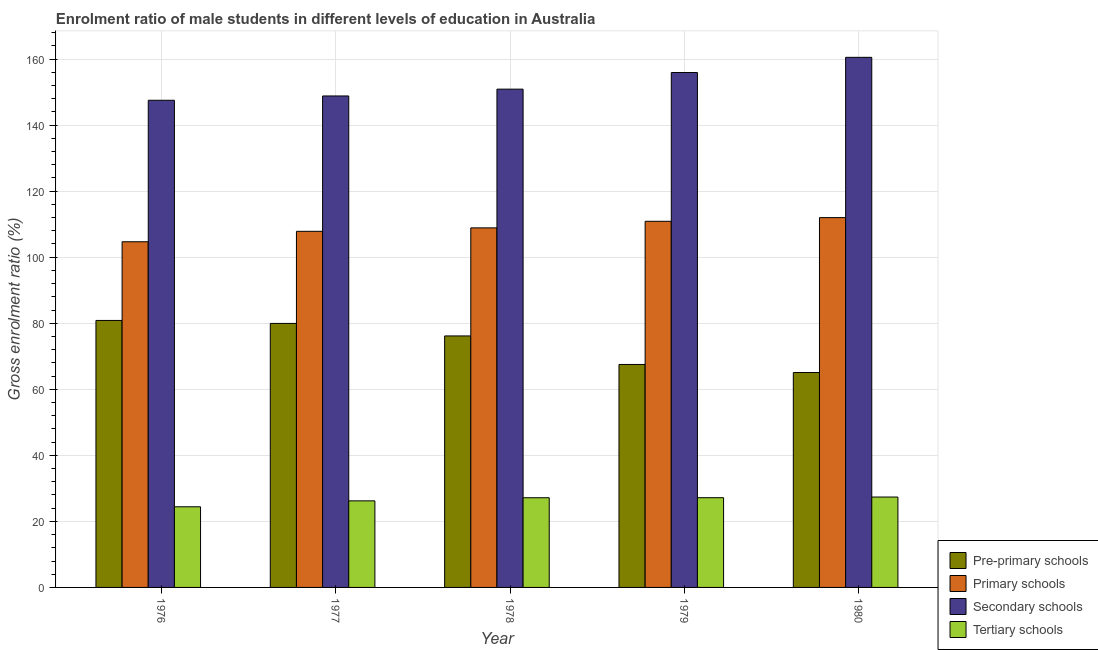How many different coloured bars are there?
Ensure brevity in your answer.  4. How many groups of bars are there?
Give a very brief answer. 5. Are the number of bars per tick equal to the number of legend labels?
Your response must be concise. Yes. Are the number of bars on each tick of the X-axis equal?
Keep it short and to the point. Yes. What is the label of the 3rd group of bars from the left?
Keep it short and to the point. 1978. What is the gross enrolment ratio(female) in tertiary schools in 1980?
Offer a very short reply. 27.37. Across all years, what is the maximum gross enrolment ratio(female) in primary schools?
Ensure brevity in your answer.  111.98. Across all years, what is the minimum gross enrolment ratio(female) in secondary schools?
Provide a succinct answer. 147.52. In which year was the gross enrolment ratio(female) in secondary schools minimum?
Ensure brevity in your answer.  1976. What is the total gross enrolment ratio(female) in secondary schools in the graph?
Keep it short and to the point. 763.66. What is the difference between the gross enrolment ratio(female) in pre-primary schools in 1977 and that in 1978?
Provide a short and direct response. 3.79. What is the difference between the gross enrolment ratio(female) in pre-primary schools in 1977 and the gross enrolment ratio(female) in tertiary schools in 1980?
Your response must be concise. 14.87. What is the average gross enrolment ratio(female) in tertiary schools per year?
Give a very brief answer. 26.47. In the year 1980, what is the difference between the gross enrolment ratio(female) in tertiary schools and gross enrolment ratio(female) in pre-primary schools?
Your response must be concise. 0. What is the ratio of the gross enrolment ratio(female) in pre-primary schools in 1977 to that in 1980?
Your answer should be very brief. 1.23. Is the gross enrolment ratio(female) in pre-primary schools in 1976 less than that in 1979?
Offer a terse response. No. Is the difference between the gross enrolment ratio(female) in primary schools in 1976 and 1980 greater than the difference between the gross enrolment ratio(female) in pre-primary schools in 1976 and 1980?
Your answer should be compact. No. What is the difference between the highest and the second highest gross enrolment ratio(female) in tertiary schools?
Provide a succinct answer. 0.2. What is the difference between the highest and the lowest gross enrolment ratio(female) in primary schools?
Provide a short and direct response. 7.31. Is the sum of the gross enrolment ratio(female) in tertiary schools in 1977 and 1979 greater than the maximum gross enrolment ratio(female) in pre-primary schools across all years?
Your answer should be compact. Yes. Is it the case that in every year, the sum of the gross enrolment ratio(female) in secondary schools and gross enrolment ratio(female) in primary schools is greater than the sum of gross enrolment ratio(female) in tertiary schools and gross enrolment ratio(female) in pre-primary schools?
Give a very brief answer. Yes. What does the 3rd bar from the left in 1979 represents?
Your response must be concise. Secondary schools. What does the 2nd bar from the right in 1979 represents?
Offer a very short reply. Secondary schools. Are all the bars in the graph horizontal?
Your answer should be compact. No. How many years are there in the graph?
Keep it short and to the point. 5. Does the graph contain any zero values?
Offer a terse response. No. Does the graph contain grids?
Give a very brief answer. Yes. Where does the legend appear in the graph?
Keep it short and to the point. Bottom right. How are the legend labels stacked?
Your answer should be very brief. Vertical. What is the title of the graph?
Keep it short and to the point. Enrolment ratio of male students in different levels of education in Australia. What is the label or title of the X-axis?
Your answer should be very brief. Year. What is the label or title of the Y-axis?
Offer a very short reply. Gross enrolment ratio (%). What is the Gross enrolment ratio (%) in Pre-primary schools in 1976?
Provide a succinct answer. 80.84. What is the Gross enrolment ratio (%) in Primary schools in 1976?
Offer a very short reply. 104.67. What is the Gross enrolment ratio (%) in Secondary schools in 1976?
Offer a terse response. 147.52. What is the Gross enrolment ratio (%) of Tertiary schools in 1976?
Offer a very short reply. 24.42. What is the Gross enrolment ratio (%) in Pre-primary schools in 1977?
Your response must be concise. 79.95. What is the Gross enrolment ratio (%) of Primary schools in 1977?
Keep it short and to the point. 107.83. What is the Gross enrolment ratio (%) of Secondary schools in 1977?
Ensure brevity in your answer.  148.82. What is the Gross enrolment ratio (%) of Tertiary schools in 1977?
Provide a short and direct response. 26.22. What is the Gross enrolment ratio (%) in Pre-primary schools in 1978?
Give a very brief answer. 76.15. What is the Gross enrolment ratio (%) of Primary schools in 1978?
Ensure brevity in your answer.  108.88. What is the Gross enrolment ratio (%) in Secondary schools in 1978?
Offer a very short reply. 150.89. What is the Gross enrolment ratio (%) of Tertiary schools in 1978?
Provide a short and direct response. 27.16. What is the Gross enrolment ratio (%) in Pre-primary schools in 1979?
Keep it short and to the point. 67.52. What is the Gross enrolment ratio (%) in Primary schools in 1979?
Offer a very short reply. 110.87. What is the Gross enrolment ratio (%) of Secondary schools in 1979?
Your answer should be very brief. 155.92. What is the Gross enrolment ratio (%) in Tertiary schools in 1979?
Offer a very short reply. 27.17. What is the Gross enrolment ratio (%) of Pre-primary schools in 1980?
Give a very brief answer. 65.08. What is the Gross enrolment ratio (%) of Primary schools in 1980?
Offer a terse response. 111.98. What is the Gross enrolment ratio (%) of Secondary schools in 1980?
Provide a succinct answer. 160.52. What is the Gross enrolment ratio (%) of Tertiary schools in 1980?
Give a very brief answer. 27.37. Across all years, what is the maximum Gross enrolment ratio (%) of Pre-primary schools?
Offer a very short reply. 80.84. Across all years, what is the maximum Gross enrolment ratio (%) of Primary schools?
Offer a very short reply. 111.98. Across all years, what is the maximum Gross enrolment ratio (%) in Secondary schools?
Make the answer very short. 160.52. Across all years, what is the maximum Gross enrolment ratio (%) in Tertiary schools?
Offer a very short reply. 27.37. Across all years, what is the minimum Gross enrolment ratio (%) of Pre-primary schools?
Provide a succinct answer. 65.08. Across all years, what is the minimum Gross enrolment ratio (%) of Primary schools?
Give a very brief answer. 104.67. Across all years, what is the minimum Gross enrolment ratio (%) in Secondary schools?
Provide a succinct answer. 147.52. Across all years, what is the minimum Gross enrolment ratio (%) in Tertiary schools?
Provide a short and direct response. 24.42. What is the total Gross enrolment ratio (%) of Pre-primary schools in the graph?
Your answer should be very brief. 369.54. What is the total Gross enrolment ratio (%) in Primary schools in the graph?
Keep it short and to the point. 544.24. What is the total Gross enrolment ratio (%) of Secondary schools in the graph?
Your answer should be compact. 763.66. What is the total Gross enrolment ratio (%) in Tertiary schools in the graph?
Offer a very short reply. 132.33. What is the difference between the Gross enrolment ratio (%) in Pre-primary schools in 1976 and that in 1977?
Offer a very short reply. 0.9. What is the difference between the Gross enrolment ratio (%) of Primary schools in 1976 and that in 1977?
Provide a succinct answer. -3.16. What is the difference between the Gross enrolment ratio (%) of Secondary schools in 1976 and that in 1977?
Keep it short and to the point. -1.31. What is the difference between the Gross enrolment ratio (%) of Tertiary schools in 1976 and that in 1977?
Provide a succinct answer. -1.8. What is the difference between the Gross enrolment ratio (%) in Pre-primary schools in 1976 and that in 1978?
Your response must be concise. 4.69. What is the difference between the Gross enrolment ratio (%) in Primary schools in 1976 and that in 1978?
Keep it short and to the point. -4.21. What is the difference between the Gross enrolment ratio (%) in Secondary schools in 1976 and that in 1978?
Make the answer very short. -3.37. What is the difference between the Gross enrolment ratio (%) of Tertiary schools in 1976 and that in 1978?
Your answer should be compact. -2.74. What is the difference between the Gross enrolment ratio (%) of Pre-primary schools in 1976 and that in 1979?
Provide a succinct answer. 13.33. What is the difference between the Gross enrolment ratio (%) of Primary schools in 1976 and that in 1979?
Make the answer very short. -6.2. What is the difference between the Gross enrolment ratio (%) of Secondary schools in 1976 and that in 1979?
Give a very brief answer. -8.4. What is the difference between the Gross enrolment ratio (%) of Tertiary schools in 1976 and that in 1979?
Offer a very short reply. -2.75. What is the difference between the Gross enrolment ratio (%) in Pre-primary schools in 1976 and that in 1980?
Ensure brevity in your answer.  15.77. What is the difference between the Gross enrolment ratio (%) in Primary schools in 1976 and that in 1980?
Offer a very short reply. -7.31. What is the difference between the Gross enrolment ratio (%) of Secondary schools in 1976 and that in 1980?
Give a very brief answer. -13. What is the difference between the Gross enrolment ratio (%) in Tertiary schools in 1976 and that in 1980?
Keep it short and to the point. -2.95. What is the difference between the Gross enrolment ratio (%) of Pre-primary schools in 1977 and that in 1978?
Provide a succinct answer. 3.79. What is the difference between the Gross enrolment ratio (%) of Primary schools in 1977 and that in 1978?
Give a very brief answer. -1.05. What is the difference between the Gross enrolment ratio (%) of Secondary schools in 1977 and that in 1978?
Your answer should be compact. -2.06. What is the difference between the Gross enrolment ratio (%) of Tertiary schools in 1977 and that in 1978?
Your response must be concise. -0.94. What is the difference between the Gross enrolment ratio (%) of Pre-primary schools in 1977 and that in 1979?
Offer a very short reply. 12.43. What is the difference between the Gross enrolment ratio (%) of Primary schools in 1977 and that in 1979?
Keep it short and to the point. -3.04. What is the difference between the Gross enrolment ratio (%) of Secondary schools in 1977 and that in 1979?
Make the answer very short. -7.1. What is the difference between the Gross enrolment ratio (%) in Tertiary schools in 1977 and that in 1979?
Your response must be concise. -0.96. What is the difference between the Gross enrolment ratio (%) in Pre-primary schools in 1977 and that in 1980?
Ensure brevity in your answer.  14.87. What is the difference between the Gross enrolment ratio (%) of Primary schools in 1977 and that in 1980?
Offer a very short reply. -4.15. What is the difference between the Gross enrolment ratio (%) of Secondary schools in 1977 and that in 1980?
Your answer should be compact. -11.7. What is the difference between the Gross enrolment ratio (%) in Tertiary schools in 1977 and that in 1980?
Make the answer very short. -1.15. What is the difference between the Gross enrolment ratio (%) in Pre-primary schools in 1978 and that in 1979?
Give a very brief answer. 8.64. What is the difference between the Gross enrolment ratio (%) in Primary schools in 1978 and that in 1979?
Your response must be concise. -1.99. What is the difference between the Gross enrolment ratio (%) of Secondary schools in 1978 and that in 1979?
Make the answer very short. -5.03. What is the difference between the Gross enrolment ratio (%) of Tertiary schools in 1978 and that in 1979?
Ensure brevity in your answer.  -0.01. What is the difference between the Gross enrolment ratio (%) in Pre-primary schools in 1978 and that in 1980?
Offer a very short reply. 11.08. What is the difference between the Gross enrolment ratio (%) in Primary schools in 1978 and that in 1980?
Provide a short and direct response. -3.1. What is the difference between the Gross enrolment ratio (%) of Secondary schools in 1978 and that in 1980?
Give a very brief answer. -9.63. What is the difference between the Gross enrolment ratio (%) in Tertiary schools in 1978 and that in 1980?
Provide a succinct answer. -0.21. What is the difference between the Gross enrolment ratio (%) in Pre-primary schools in 1979 and that in 1980?
Keep it short and to the point. 2.44. What is the difference between the Gross enrolment ratio (%) of Primary schools in 1979 and that in 1980?
Give a very brief answer. -1.11. What is the difference between the Gross enrolment ratio (%) in Secondary schools in 1979 and that in 1980?
Offer a very short reply. -4.6. What is the difference between the Gross enrolment ratio (%) in Tertiary schools in 1979 and that in 1980?
Provide a succinct answer. -0.2. What is the difference between the Gross enrolment ratio (%) of Pre-primary schools in 1976 and the Gross enrolment ratio (%) of Primary schools in 1977?
Your response must be concise. -26.99. What is the difference between the Gross enrolment ratio (%) in Pre-primary schools in 1976 and the Gross enrolment ratio (%) in Secondary schools in 1977?
Your answer should be very brief. -67.98. What is the difference between the Gross enrolment ratio (%) of Pre-primary schools in 1976 and the Gross enrolment ratio (%) of Tertiary schools in 1977?
Your answer should be compact. 54.63. What is the difference between the Gross enrolment ratio (%) of Primary schools in 1976 and the Gross enrolment ratio (%) of Secondary schools in 1977?
Offer a terse response. -44.15. What is the difference between the Gross enrolment ratio (%) in Primary schools in 1976 and the Gross enrolment ratio (%) in Tertiary schools in 1977?
Provide a short and direct response. 78.46. What is the difference between the Gross enrolment ratio (%) in Secondary schools in 1976 and the Gross enrolment ratio (%) in Tertiary schools in 1977?
Your answer should be compact. 121.3. What is the difference between the Gross enrolment ratio (%) of Pre-primary schools in 1976 and the Gross enrolment ratio (%) of Primary schools in 1978?
Keep it short and to the point. -28.04. What is the difference between the Gross enrolment ratio (%) of Pre-primary schools in 1976 and the Gross enrolment ratio (%) of Secondary schools in 1978?
Your answer should be very brief. -70.04. What is the difference between the Gross enrolment ratio (%) in Pre-primary schools in 1976 and the Gross enrolment ratio (%) in Tertiary schools in 1978?
Your answer should be very brief. 53.69. What is the difference between the Gross enrolment ratio (%) of Primary schools in 1976 and the Gross enrolment ratio (%) of Secondary schools in 1978?
Provide a succinct answer. -46.21. What is the difference between the Gross enrolment ratio (%) in Primary schools in 1976 and the Gross enrolment ratio (%) in Tertiary schools in 1978?
Your answer should be very brief. 77.51. What is the difference between the Gross enrolment ratio (%) of Secondary schools in 1976 and the Gross enrolment ratio (%) of Tertiary schools in 1978?
Ensure brevity in your answer.  120.36. What is the difference between the Gross enrolment ratio (%) in Pre-primary schools in 1976 and the Gross enrolment ratio (%) in Primary schools in 1979?
Offer a terse response. -30.03. What is the difference between the Gross enrolment ratio (%) in Pre-primary schools in 1976 and the Gross enrolment ratio (%) in Secondary schools in 1979?
Offer a very short reply. -75.07. What is the difference between the Gross enrolment ratio (%) in Pre-primary schools in 1976 and the Gross enrolment ratio (%) in Tertiary schools in 1979?
Your answer should be very brief. 53.67. What is the difference between the Gross enrolment ratio (%) in Primary schools in 1976 and the Gross enrolment ratio (%) in Secondary schools in 1979?
Give a very brief answer. -51.25. What is the difference between the Gross enrolment ratio (%) in Primary schools in 1976 and the Gross enrolment ratio (%) in Tertiary schools in 1979?
Your answer should be compact. 77.5. What is the difference between the Gross enrolment ratio (%) in Secondary schools in 1976 and the Gross enrolment ratio (%) in Tertiary schools in 1979?
Offer a very short reply. 120.34. What is the difference between the Gross enrolment ratio (%) of Pre-primary schools in 1976 and the Gross enrolment ratio (%) of Primary schools in 1980?
Your response must be concise. -31.14. What is the difference between the Gross enrolment ratio (%) in Pre-primary schools in 1976 and the Gross enrolment ratio (%) in Secondary schools in 1980?
Your response must be concise. -79.68. What is the difference between the Gross enrolment ratio (%) of Pre-primary schools in 1976 and the Gross enrolment ratio (%) of Tertiary schools in 1980?
Provide a short and direct response. 53.48. What is the difference between the Gross enrolment ratio (%) of Primary schools in 1976 and the Gross enrolment ratio (%) of Secondary schools in 1980?
Provide a short and direct response. -55.85. What is the difference between the Gross enrolment ratio (%) of Primary schools in 1976 and the Gross enrolment ratio (%) of Tertiary schools in 1980?
Provide a short and direct response. 77.3. What is the difference between the Gross enrolment ratio (%) in Secondary schools in 1976 and the Gross enrolment ratio (%) in Tertiary schools in 1980?
Keep it short and to the point. 120.15. What is the difference between the Gross enrolment ratio (%) in Pre-primary schools in 1977 and the Gross enrolment ratio (%) in Primary schools in 1978?
Give a very brief answer. -28.93. What is the difference between the Gross enrolment ratio (%) in Pre-primary schools in 1977 and the Gross enrolment ratio (%) in Secondary schools in 1978?
Your answer should be very brief. -70.94. What is the difference between the Gross enrolment ratio (%) of Pre-primary schools in 1977 and the Gross enrolment ratio (%) of Tertiary schools in 1978?
Provide a succinct answer. 52.79. What is the difference between the Gross enrolment ratio (%) in Primary schools in 1977 and the Gross enrolment ratio (%) in Secondary schools in 1978?
Your answer should be compact. -43.05. What is the difference between the Gross enrolment ratio (%) in Primary schools in 1977 and the Gross enrolment ratio (%) in Tertiary schools in 1978?
Give a very brief answer. 80.67. What is the difference between the Gross enrolment ratio (%) of Secondary schools in 1977 and the Gross enrolment ratio (%) of Tertiary schools in 1978?
Offer a very short reply. 121.66. What is the difference between the Gross enrolment ratio (%) in Pre-primary schools in 1977 and the Gross enrolment ratio (%) in Primary schools in 1979?
Your response must be concise. -30.93. What is the difference between the Gross enrolment ratio (%) of Pre-primary schools in 1977 and the Gross enrolment ratio (%) of Secondary schools in 1979?
Your response must be concise. -75.97. What is the difference between the Gross enrolment ratio (%) of Pre-primary schools in 1977 and the Gross enrolment ratio (%) of Tertiary schools in 1979?
Your answer should be very brief. 52.78. What is the difference between the Gross enrolment ratio (%) in Primary schools in 1977 and the Gross enrolment ratio (%) in Secondary schools in 1979?
Offer a very short reply. -48.09. What is the difference between the Gross enrolment ratio (%) in Primary schools in 1977 and the Gross enrolment ratio (%) in Tertiary schools in 1979?
Keep it short and to the point. 80.66. What is the difference between the Gross enrolment ratio (%) of Secondary schools in 1977 and the Gross enrolment ratio (%) of Tertiary schools in 1979?
Offer a very short reply. 121.65. What is the difference between the Gross enrolment ratio (%) in Pre-primary schools in 1977 and the Gross enrolment ratio (%) in Primary schools in 1980?
Ensure brevity in your answer.  -32.04. What is the difference between the Gross enrolment ratio (%) of Pre-primary schools in 1977 and the Gross enrolment ratio (%) of Secondary schools in 1980?
Ensure brevity in your answer.  -80.57. What is the difference between the Gross enrolment ratio (%) in Pre-primary schools in 1977 and the Gross enrolment ratio (%) in Tertiary schools in 1980?
Your response must be concise. 52.58. What is the difference between the Gross enrolment ratio (%) of Primary schools in 1977 and the Gross enrolment ratio (%) of Secondary schools in 1980?
Ensure brevity in your answer.  -52.69. What is the difference between the Gross enrolment ratio (%) of Primary schools in 1977 and the Gross enrolment ratio (%) of Tertiary schools in 1980?
Your answer should be very brief. 80.46. What is the difference between the Gross enrolment ratio (%) of Secondary schools in 1977 and the Gross enrolment ratio (%) of Tertiary schools in 1980?
Your answer should be compact. 121.45. What is the difference between the Gross enrolment ratio (%) in Pre-primary schools in 1978 and the Gross enrolment ratio (%) in Primary schools in 1979?
Keep it short and to the point. -34.72. What is the difference between the Gross enrolment ratio (%) of Pre-primary schools in 1978 and the Gross enrolment ratio (%) of Secondary schools in 1979?
Offer a terse response. -79.76. What is the difference between the Gross enrolment ratio (%) of Pre-primary schools in 1978 and the Gross enrolment ratio (%) of Tertiary schools in 1979?
Your response must be concise. 48.98. What is the difference between the Gross enrolment ratio (%) in Primary schools in 1978 and the Gross enrolment ratio (%) in Secondary schools in 1979?
Offer a very short reply. -47.04. What is the difference between the Gross enrolment ratio (%) of Primary schools in 1978 and the Gross enrolment ratio (%) of Tertiary schools in 1979?
Provide a succinct answer. 81.71. What is the difference between the Gross enrolment ratio (%) in Secondary schools in 1978 and the Gross enrolment ratio (%) in Tertiary schools in 1979?
Ensure brevity in your answer.  123.71. What is the difference between the Gross enrolment ratio (%) of Pre-primary schools in 1978 and the Gross enrolment ratio (%) of Primary schools in 1980?
Offer a terse response. -35.83. What is the difference between the Gross enrolment ratio (%) in Pre-primary schools in 1978 and the Gross enrolment ratio (%) in Secondary schools in 1980?
Your answer should be very brief. -84.37. What is the difference between the Gross enrolment ratio (%) in Pre-primary schools in 1978 and the Gross enrolment ratio (%) in Tertiary schools in 1980?
Your answer should be very brief. 48.79. What is the difference between the Gross enrolment ratio (%) in Primary schools in 1978 and the Gross enrolment ratio (%) in Secondary schools in 1980?
Provide a short and direct response. -51.64. What is the difference between the Gross enrolment ratio (%) in Primary schools in 1978 and the Gross enrolment ratio (%) in Tertiary schools in 1980?
Offer a terse response. 81.51. What is the difference between the Gross enrolment ratio (%) in Secondary schools in 1978 and the Gross enrolment ratio (%) in Tertiary schools in 1980?
Your answer should be compact. 123.52. What is the difference between the Gross enrolment ratio (%) in Pre-primary schools in 1979 and the Gross enrolment ratio (%) in Primary schools in 1980?
Make the answer very short. -44.47. What is the difference between the Gross enrolment ratio (%) in Pre-primary schools in 1979 and the Gross enrolment ratio (%) in Secondary schools in 1980?
Give a very brief answer. -93. What is the difference between the Gross enrolment ratio (%) of Pre-primary schools in 1979 and the Gross enrolment ratio (%) of Tertiary schools in 1980?
Provide a short and direct response. 40.15. What is the difference between the Gross enrolment ratio (%) in Primary schools in 1979 and the Gross enrolment ratio (%) in Secondary schools in 1980?
Ensure brevity in your answer.  -49.65. What is the difference between the Gross enrolment ratio (%) of Primary schools in 1979 and the Gross enrolment ratio (%) of Tertiary schools in 1980?
Your answer should be very brief. 83.5. What is the difference between the Gross enrolment ratio (%) of Secondary schools in 1979 and the Gross enrolment ratio (%) of Tertiary schools in 1980?
Your answer should be very brief. 128.55. What is the average Gross enrolment ratio (%) in Pre-primary schools per year?
Offer a very short reply. 73.91. What is the average Gross enrolment ratio (%) in Primary schools per year?
Give a very brief answer. 108.85. What is the average Gross enrolment ratio (%) in Secondary schools per year?
Your answer should be very brief. 152.73. What is the average Gross enrolment ratio (%) of Tertiary schools per year?
Provide a short and direct response. 26.47. In the year 1976, what is the difference between the Gross enrolment ratio (%) of Pre-primary schools and Gross enrolment ratio (%) of Primary schools?
Keep it short and to the point. -23.83. In the year 1976, what is the difference between the Gross enrolment ratio (%) of Pre-primary schools and Gross enrolment ratio (%) of Secondary schools?
Make the answer very short. -66.67. In the year 1976, what is the difference between the Gross enrolment ratio (%) of Pre-primary schools and Gross enrolment ratio (%) of Tertiary schools?
Keep it short and to the point. 56.43. In the year 1976, what is the difference between the Gross enrolment ratio (%) in Primary schools and Gross enrolment ratio (%) in Secondary schools?
Provide a short and direct response. -42.84. In the year 1976, what is the difference between the Gross enrolment ratio (%) in Primary schools and Gross enrolment ratio (%) in Tertiary schools?
Make the answer very short. 80.26. In the year 1976, what is the difference between the Gross enrolment ratio (%) in Secondary schools and Gross enrolment ratio (%) in Tertiary schools?
Make the answer very short. 123.1. In the year 1977, what is the difference between the Gross enrolment ratio (%) in Pre-primary schools and Gross enrolment ratio (%) in Primary schools?
Make the answer very short. -27.89. In the year 1977, what is the difference between the Gross enrolment ratio (%) in Pre-primary schools and Gross enrolment ratio (%) in Secondary schools?
Keep it short and to the point. -68.88. In the year 1977, what is the difference between the Gross enrolment ratio (%) of Pre-primary schools and Gross enrolment ratio (%) of Tertiary schools?
Offer a very short reply. 53.73. In the year 1977, what is the difference between the Gross enrolment ratio (%) of Primary schools and Gross enrolment ratio (%) of Secondary schools?
Provide a succinct answer. -40.99. In the year 1977, what is the difference between the Gross enrolment ratio (%) in Primary schools and Gross enrolment ratio (%) in Tertiary schools?
Ensure brevity in your answer.  81.62. In the year 1977, what is the difference between the Gross enrolment ratio (%) in Secondary schools and Gross enrolment ratio (%) in Tertiary schools?
Offer a very short reply. 122.61. In the year 1978, what is the difference between the Gross enrolment ratio (%) of Pre-primary schools and Gross enrolment ratio (%) of Primary schools?
Make the answer very short. -32.72. In the year 1978, what is the difference between the Gross enrolment ratio (%) of Pre-primary schools and Gross enrolment ratio (%) of Secondary schools?
Ensure brevity in your answer.  -74.73. In the year 1978, what is the difference between the Gross enrolment ratio (%) in Pre-primary schools and Gross enrolment ratio (%) in Tertiary schools?
Make the answer very short. 49. In the year 1978, what is the difference between the Gross enrolment ratio (%) in Primary schools and Gross enrolment ratio (%) in Secondary schools?
Keep it short and to the point. -42.01. In the year 1978, what is the difference between the Gross enrolment ratio (%) of Primary schools and Gross enrolment ratio (%) of Tertiary schools?
Your answer should be compact. 81.72. In the year 1978, what is the difference between the Gross enrolment ratio (%) of Secondary schools and Gross enrolment ratio (%) of Tertiary schools?
Provide a succinct answer. 123.73. In the year 1979, what is the difference between the Gross enrolment ratio (%) of Pre-primary schools and Gross enrolment ratio (%) of Primary schools?
Give a very brief answer. -43.36. In the year 1979, what is the difference between the Gross enrolment ratio (%) in Pre-primary schools and Gross enrolment ratio (%) in Secondary schools?
Offer a terse response. -88.4. In the year 1979, what is the difference between the Gross enrolment ratio (%) of Pre-primary schools and Gross enrolment ratio (%) of Tertiary schools?
Offer a very short reply. 40.34. In the year 1979, what is the difference between the Gross enrolment ratio (%) in Primary schools and Gross enrolment ratio (%) in Secondary schools?
Offer a very short reply. -45.04. In the year 1979, what is the difference between the Gross enrolment ratio (%) in Primary schools and Gross enrolment ratio (%) in Tertiary schools?
Provide a succinct answer. 83.7. In the year 1979, what is the difference between the Gross enrolment ratio (%) in Secondary schools and Gross enrolment ratio (%) in Tertiary schools?
Provide a short and direct response. 128.75. In the year 1980, what is the difference between the Gross enrolment ratio (%) in Pre-primary schools and Gross enrolment ratio (%) in Primary schools?
Your response must be concise. -46.9. In the year 1980, what is the difference between the Gross enrolment ratio (%) of Pre-primary schools and Gross enrolment ratio (%) of Secondary schools?
Your answer should be very brief. -95.44. In the year 1980, what is the difference between the Gross enrolment ratio (%) in Pre-primary schools and Gross enrolment ratio (%) in Tertiary schools?
Provide a short and direct response. 37.71. In the year 1980, what is the difference between the Gross enrolment ratio (%) of Primary schools and Gross enrolment ratio (%) of Secondary schools?
Offer a terse response. -48.54. In the year 1980, what is the difference between the Gross enrolment ratio (%) of Primary schools and Gross enrolment ratio (%) of Tertiary schools?
Provide a short and direct response. 84.61. In the year 1980, what is the difference between the Gross enrolment ratio (%) of Secondary schools and Gross enrolment ratio (%) of Tertiary schools?
Your response must be concise. 133.15. What is the ratio of the Gross enrolment ratio (%) of Pre-primary schools in 1976 to that in 1977?
Provide a short and direct response. 1.01. What is the ratio of the Gross enrolment ratio (%) in Primary schools in 1976 to that in 1977?
Provide a short and direct response. 0.97. What is the ratio of the Gross enrolment ratio (%) in Tertiary schools in 1976 to that in 1977?
Ensure brevity in your answer.  0.93. What is the ratio of the Gross enrolment ratio (%) in Pre-primary schools in 1976 to that in 1978?
Offer a very short reply. 1.06. What is the ratio of the Gross enrolment ratio (%) in Primary schools in 1976 to that in 1978?
Offer a terse response. 0.96. What is the ratio of the Gross enrolment ratio (%) of Secondary schools in 1976 to that in 1978?
Make the answer very short. 0.98. What is the ratio of the Gross enrolment ratio (%) of Tertiary schools in 1976 to that in 1978?
Offer a terse response. 0.9. What is the ratio of the Gross enrolment ratio (%) of Pre-primary schools in 1976 to that in 1979?
Provide a succinct answer. 1.2. What is the ratio of the Gross enrolment ratio (%) in Primary schools in 1976 to that in 1979?
Offer a very short reply. 0.94. What is the ratio of the Gross enrolment ratio (%) of Secondary schools in 1976 to that in 1979?
Ensure brevity in your answer.  0.95. What is the ratio of the Gross enrolment ratio (%) in Tertiary schools in 1976 to that in 1979?
Your response must be concise. 0.9. What is the ratio of the Gross enrolment ratio (%) of Pre-primary schools in 1976 to that in 1980?
Ensure brevity in your answer.  1.24. What is the ratio of the Gross enrolment ratio (%) of Primary schools in 1976 to that in 1980?
Provide a short and direct response. 0.93. What is the ratio of the Gross enrolment ratio (%) of Secondary schools in 1976 to that in 1980?
Your answer should be compact. 0.92. What is the ratio of the Gross enrolment ratio (%) in Tertiary schools in 1976 to that in 1980?
Your response must be concise. 0.89. What is the ratio of the Gross enrolment ratio (%) in Pre-primary schools in 1977 to that in 1978?
Give a very brief answer. 1.05. What is the ratio of the Gross enrolment ratio (%) in Primary schools in 1977 to that in 1978?
Your response must be concise. 0.99. What is the ratio of the Gross enrolment ratio (%) of Secondary schools in 1977 to that in 1978?
Ensure brevity in your answer.  0.99. What is the ratio of the Gross enrolment ratio (%) in Tertiary schools in 1977 to that in 1978?
Make the answer very short. 0.97. What is the ratio of the Gross enrolment ratio (%) of Pre-primary schools in 1977 to that in 1979?
Ensure brevity in your answer.  1.18. What is the ratio of the Gross enrolment ratio (%) of Primary schools in 1977 to that in 1979?
Your answer should be very brief. 0.97. What is the ratio of the Gross enrolment ratio (%) of Secondary schools in 1977 to that in 1979?
Your response must be concise. 0.95. What is the ratio of the Gross enrolment ratio (%) in Tertiary schools in 1977 to that in 1979?
Give a very brief answer. 0.96. What is the ratio of the Gross enrolment ratio (%) in Pre-primary schools in 1977 to that in 1980?
Your answer should be compact. 1.23. What is the ratio of the Gross enrolment ratio (%) in Secondary schools in 1977 to that in 1980?
Offer a very short reply. 0.93. What is the ratio of the Gross enrolment ratio (%) in Tertiary schools in 1977 to that in 1980?
Give a very brief answer. 0.96. What is the ratio of the Gross enrolment ratio (%) of Pre-primary schools in 1978 to that in 1979?
Provide a short and direct response. 1.13. What is the ratio of the Gross enrolment ratio (%) in Secondary schools in 1978 to that in 1979?
Keep it short and to the point. 0.97. What is the ratio of the Gross enrolment ratio (%) in Pre-primary schools in 1978 to that in 1980?
Offer a terse response. 1.17. What is the ratio of the Gross enrolment ratio (%) of Primary schools in 1978 to that in 1980?
Your answer should be compact. 0.97. What is the ratio of the Gross enrolment ratio (%) in Pre-primary schools in 1979 to that in 1980?
Give a very brief answer. 1.04. What is the ratio of the Gross enrolment ratio (%) in Secondary schools in 1979 to that in 1980?
Your answer should be very brief. 0.97. What is the ratio of the Gross enrolment ratio (%) in Tertiary schools in 1979 to that in 1980?
Offer a very short reply. 0.99. What is the difference between the highest and the second highest Gross enrolment ratio (%) in Pre-primary schools?
Provide a succinct answer. 0.9. What is the difference between the highest and the second highest Gross enrolment ratio (%) of Primary schools?
Give a very brief answer. 1.11. What is the difference between the highest and the second highest Gross enrolment ratio (%) in Secondary schools?
Give a very brief answer. 4.6. What is the difference between the highest and the second highest Gross enrolment ratio (%) of Tertiary schools?
Offer a terse response. 0.2. What is the difference between the highest and the lowest Gross enrolment ratio (%) in Pre-primary schools?
Give a very brief answer. 15.77. What is the difference between the highest and the lowest Gross enrolment ratio (%) in Primary schools?
Your response must be concise. 7.31. What is the difference between the highest and the lowest Gross enrolment ratio (%) in Secondary schools?
Make the answer very short. 13. What is the difference between the highest and the lowest Gross enrolment ratio (%) in Tertiary schools?
Make the answer very short. 2.95. 